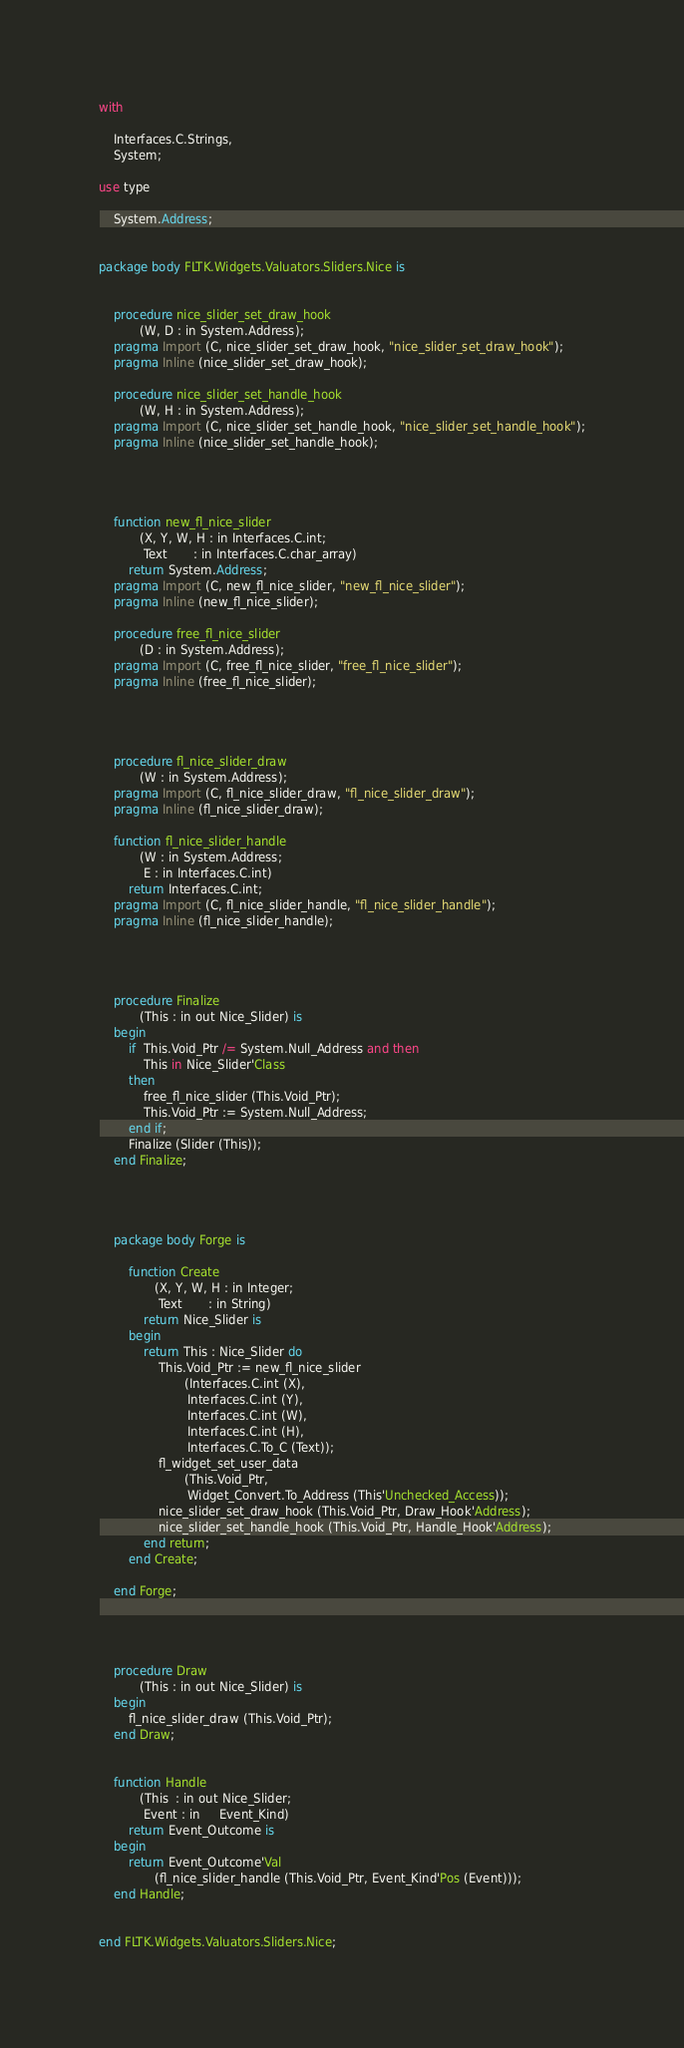Convert code to text. <code><loc_0><loc_0><loc_500><loc_500><_Ada_>

with

    Interfaces.C.Strings,
    System;

use type

    System.Address;


package body FLTK.Widgets.Valuators.Sliders.Nice is


    procedure nice_slider_set_draw_hook
           (W, D : in System.Address);
    pragma Import (C, nice_slider_set_draw_hook, "nice_slider_set_draw_hook");
    pragma Inline (nice_slider_set_draw_hook);

    procedure nice_slider_set_handle_hook
           (W, H : in System.Address);
    pragma Import (C, nice_slider_set_handle_hook, "nice_slider_set_handle_hook");
    pragma Inline (nice_slider_set_handle_hook);




    function new_fl_nice_slider
           (X, Y, W, H : in Interfaces.C.int;
            Text       : in Interfaces.C.char_array)
        return System.Address;
    pragma Import (C, new_fl_nice_slider, "new_fl_nice_slider");
    pragma Inline (new_fl_nice_slider);

    procedure free_fl_nice_slider
           (D : in System.Address);
    pragma Import (C, free_fl_nice_slider, "free_fl_nice_slider");
    pragma Inline (free_fl_nice_slider);




    procedure fl_nice_slider_draw
           (W : in System.Address);
    pragma Import (C, fl_nice_slider_draw, "fl_nice_slider_draw");
    pragma Inline (fl_nice_slider_draw);

    function fl_nice_slider_handle
           (W : in System.Address;
            E : in Interfaces.C.int)
        return Interfaces.C.int;
    pragma Import (C, fl_nice_slider_handle, "fl_nice_slider_handle");
    pragma Inline (fl_nice_slider_handle);




    procedure Finalize
           (This : in out Nice_Slider) is
    begin
        if  This.Void_Ptr /= System.Null_Address and then
            This in Nice_Slider'Class
        then
            free_fl_nice_slider (This.Void_Ptr);
            This.Void_Ptr := System.Null_Address;
        end if;
        Finalize (Slider (This));
    end Finalize;




    package body Forge is

        function Create
               (X, Y, W, H : in Integer;
                Text       : in String)
            return Nice_Slider is
        begin
            return This : Nice_Slider do
                This.Void_Ptr := new_fl_nice_slider
                       (Interfaces.C.int (X),
                        Interfaces.C.int (Y),
                        Interfaces.C.int (W),
                        Interfaces.C.int (H),
                        Interfaces.C.To_C (Text));
                fl_widget_set_user_data
                       (This.Void_Ptr,
                        Widget_Convert.To_Address (This'Unchecked_Access));
                nice_slider_set_draw_hook (This.Void_Ptr, Draw_Hook'Address);
                nice_slider_set_handle_hook (This.Void_Ptr, Handle_Hook'Address);
            end return;
        end Create;

    end Forge;




    procedure Draw
           (This : in out Nice_Slider) is
    begin
        fl_nice_slider_draw (This.Void_Ptr);
    end Draw;


    function Handle
           (This  : in out Nice_Slider;
            Event : in     Event_Kind)
        return Event_Outcome is
    begin
        return Event_Outcome'Val
               (fl_nice_slider_handle (This.Void_Ptr, Event_Kind'Pos (Event)));
    end Handle;


end FLTK.Widgets.Valuators.Sliders.Nice;

</code> 